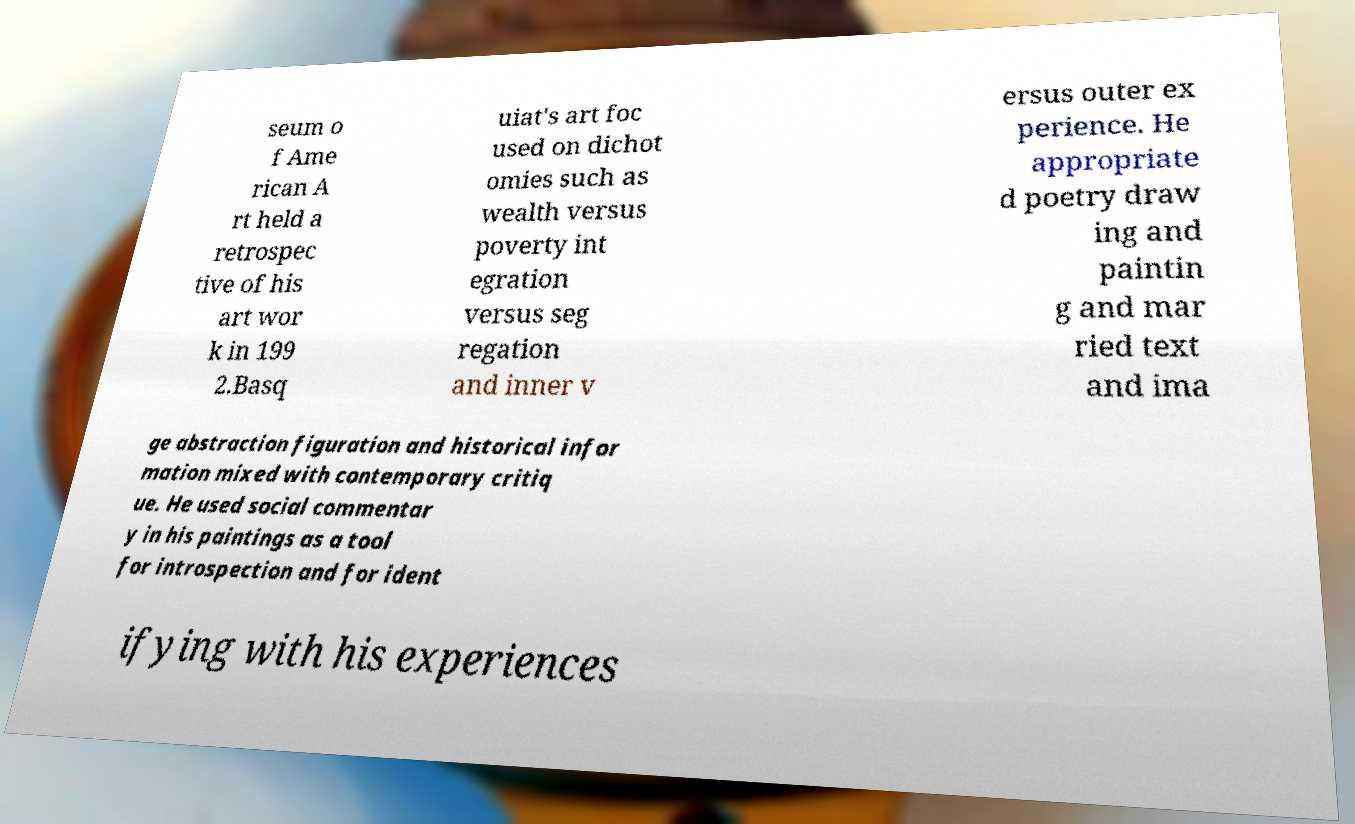There's text embedded in this image that I need extracted. Can you transcribe it verbatim? seum o f Ame rican A rt held a retrospec tive of his art wor k in 199 2.Basq uiat's art foc used on dichot omies such as wealth versus poverty int egration versus seg regation and inner v ersus outer ex perience. He appropriate d poetry draw ing and paintin g and mar ried text and ima ge abstraction figuration and historical infor mation mixed with contemporary critiq ue. He used social commentar y in his paintings as a tool for introspection and for ident ifying with his experiences 